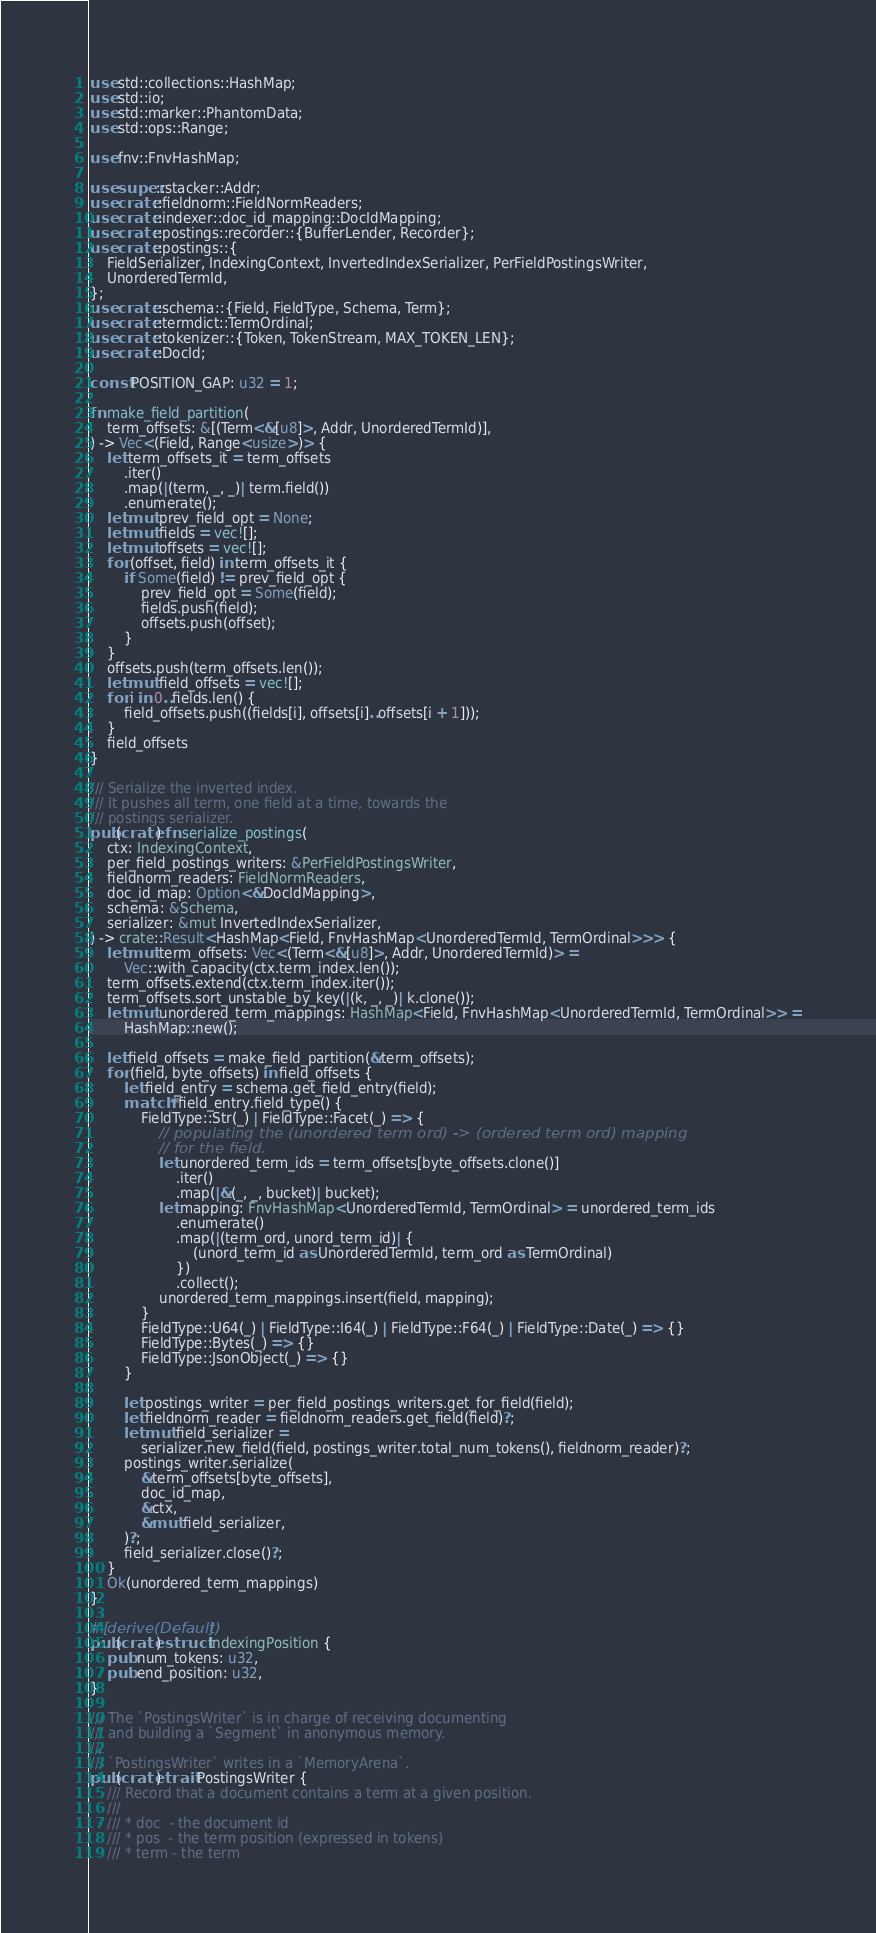Convert code to text. <code><loc_0><loc_0><loc_500><loc_500><_Rust_>use std::collections::HashMap;
use std::io;
use std::marker::PhantomData;
use std::ops::Range;

use fnv::FnvHashMap;

use super::stacker::Addr;
use crate::fieldnorm::FieldNormReaders;
use crate::indexer::doc_id_mapping::DocIdMapping;
use crate::postings::recorder::{BufferLender, Recorder};
use crate::postings::{
    FieldSerializer, IndexingContext, InvertedIndexSerializer, PerFieldPostingsWriter,
    UnorderedTermId,
};
use crate::schema::{Field, FieldType, Schema, Term};
use crate::termdict::TermOrdinal;
use crate::tokenizer::{Token, TokenStream, MAX_TOKEN_LEN};
use crate::DocId;

const POSITION_GAP: u32 = 1;

fn make_field_partition(
    term_offsets: &[(Term<&[u8]>, Addr, UnorderedTermId)],
) -> Vec<(Field, Range<usize>)> {
    let term_offsets_it = term_offsets
        .iter()
        .map(|(term, _, _)| term.field())
        .enumerate();
    let mut prev_field_opt = None;
    let mut fields = vec![];
    let mut offsets = vec![];
    for (offset, field) in term_offsets_it {
        if Some(field) != prev_field_opt {
            prev_field_opt = Some(field);
            fields.push(field);
            offsets.push(offset);
        }
    }
    offsets.push(term_offsets.len());
    let mut field_offsets = vec![];
    for i in 0..fields.len() {
        field_offsets.push((fields[i], offsets[i]..offsets[i + 1]));
    }
    field_offsets
}

/// Serialize the inverted index.
/// It pushes all term, one field at a time, towards the
/// postings serializer.
pub(crate) fn serialize_postings(
    ctx: IndexingContext,
    per_field_postings_writers: &PerFieldPostingsWriter,
    fieldnorm_readers: FieldNormReaders,
    doc_id_map: Option<&DocIdMapping>,
    schema: &Schema,
    serializer: &mut InvertedIndexSerializer,
) -> crate::Result<HashMap<Field, FnvHashMap<UnorderedTermId, TermOrdinal>>> {
    let mut term_offsets: Vec<(Term<&[u8]>, Addr, UnorderedTermId)> =
        Vec::with_capacity(ctx.term_index.len());
    term_offsets.extend(ctx.term_index.iter());
    term_offsets.sort_unstable_by_key(|(k, _, _)| k.clone());
    let mut unordered_term_mappings: HashMap<Field, FnvHashMap<UnorderedTermId, TermOrdinal>> =
        HashMap::new();

    let field_offsets = make_field_partition(&term_offsets);
    for (field, byte_offsets) in field_offsets {
        let field_entry = schema.get_field_entry(field);
        match *field_entry.field_type() {
            FieldType::Str(_) | FieldType::Facet(_) => {
                // populating the (unordered term ord) -> (ordered term ord) mapping
                // for the field.
                let unordered_term_ids = term_offsets[byte_offsets.clone()]
                    .iter()
                    .map(|&(_, _, bucket)| bucket);
                let mapping: FnvHashMap<UnorderedTermId, TermOrdinal> = unordered_term_ids
                    .enumerate()
                    .map(|(term_ord, unord_term_id)| {
                        (unord_term_id as UnorderedTermId, term_ord as TermOrdinal)
                    })
                    .collect();
                unordered_term_mappings.insert(field, mapping);
            }
            FieldType::U64(_) | FieldType::I64(_) | FieldType::F64(_) | FieldType::Date(_) => {}
            FieldType::Bytes(_) => {}
            FieldType::JsonObject(_) => {}
        }

        let postings_writer = per_field_postings_writers.get_for_field(field);
        let fieldnorm_reader = fieldnorm_readers.get_field(field)?;
        let mut field_serializer =
            serializer.new_field(field, postings_writer.total_num_tokens(), fieldnorm_reader)?;
        postings_writer.serialize(
            &term_offsets[byte_offsets],
            doc_id_map,
            &ctx,
            &mut field_serializer,
        )?;
        field_serializer.close()?;
    }
    Ok(unordered_term_mappings)
}

#[derive(Default)]
pub(crate) struct IndexingPosition {
    pub num_tokens: u32,
    pub end_position: u32,
}

/// The `PostingsWriter` is in charge of receiving documenting
/// and building a `Segment` in anonymous memory.
///
/// `PostingsWriter` writes in a `MemoryArena`.
pub(crate) trait PostingsWriter {
    /// Record that a document contains a term at a given position.
    ///
    /// * doc  - the document id
    /// * pos  - the term position (expressed in tokens)
    /// * term - the term</code> 